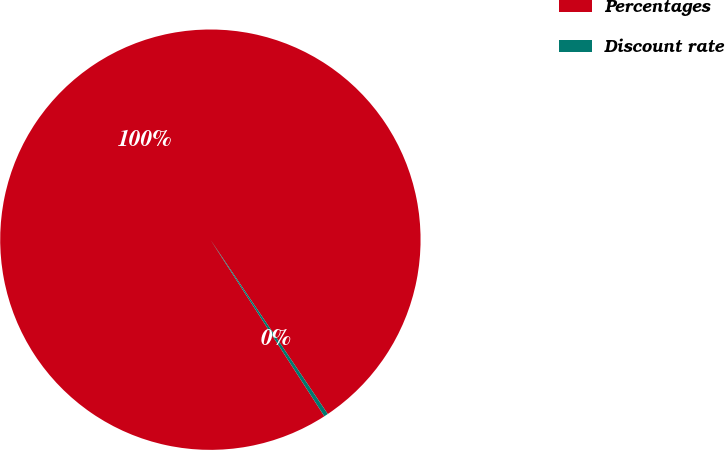Convert chart to OTSL. <chart><loc_0><loc_0><loc_500><loc_500><pie_chart><fcel>Percentages<fcel>Discount rate<nl><fcel>99.69%<fcel>0.31%<nl></chart> 